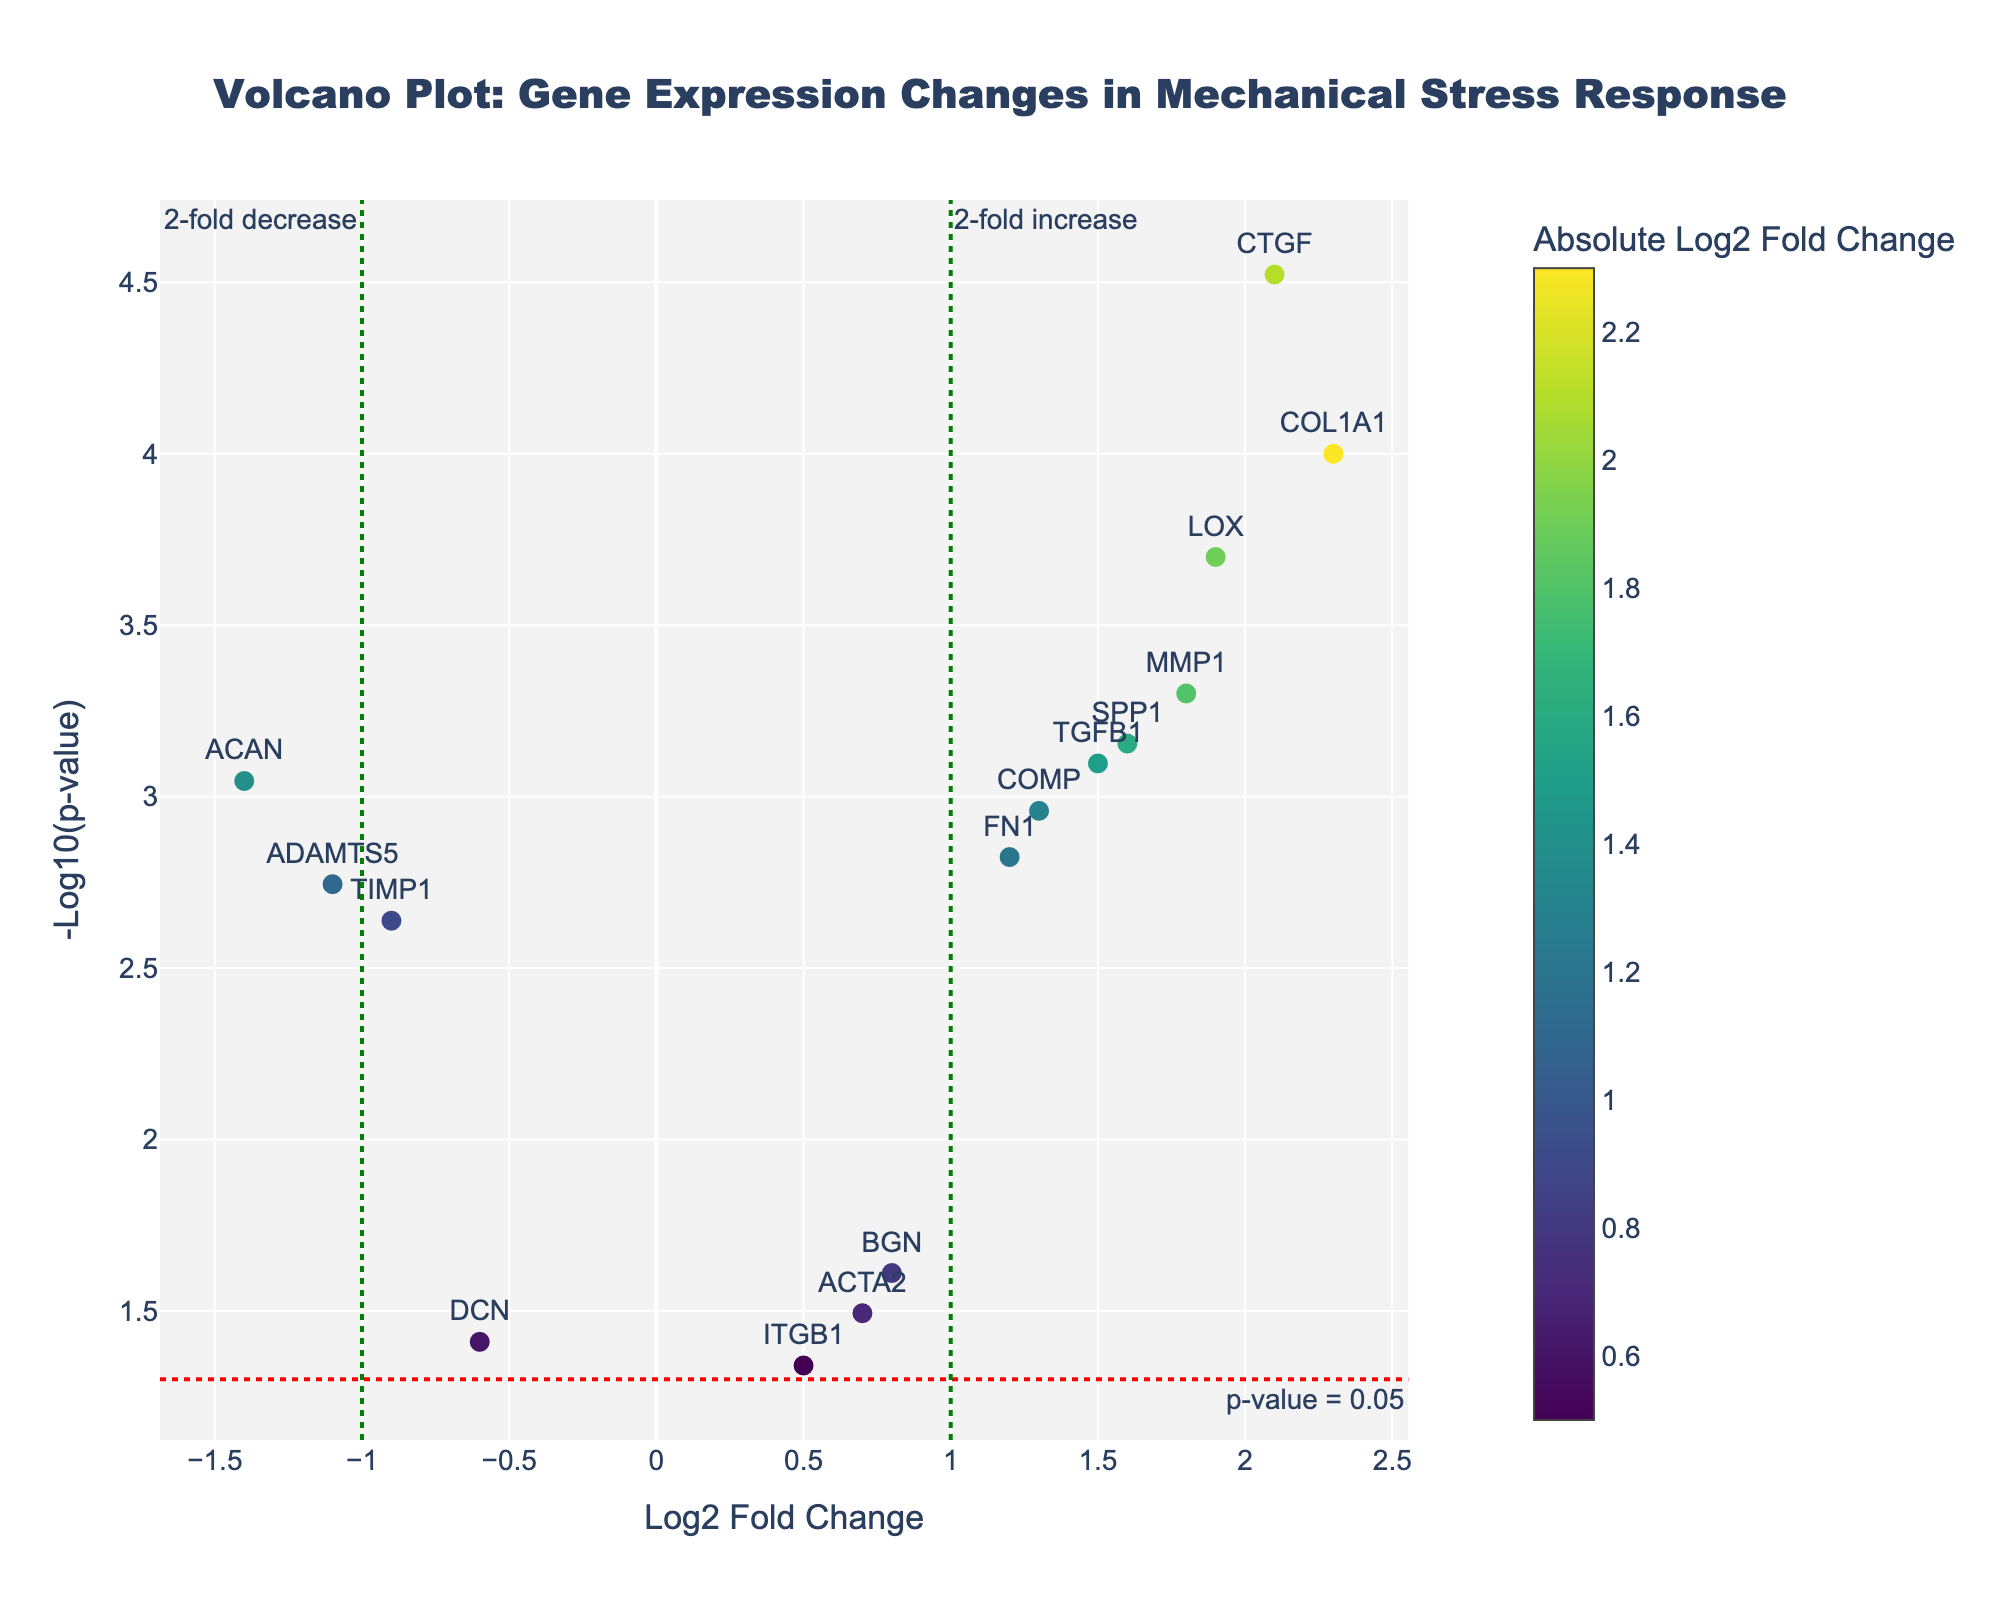What is the gene with the highest -log10(p-value)? Look for the data point with the highest value on the y-axis, which represents -log10(p-value). The gene corresponding to this point is CTGF.
Answer: CTGF How many genes have a log2 fold change greater than 2? Count the number of data points to the right of the vertical line at x=2 on the x-axis. There are no genes with a log2 fold change greater than 2.
Answer: 0 Which gene has the smallest p-value? The smallest p-value corresponds to the largest -log10(p-value). Identify the gene associated with the highest value on the y-axis. The gene is CTGF.
Answer: CTGF For the gene ADAMTS5, what is the log2 fold change and p-value? Locate the data point labeled ADAMTS5 and check its position in terms of x and y coordinates. The log2 fold change is -1.1, and the p-value (converted from -log10(p-value)) is approximately 0.0018.
Answer: -1.1 and 0.0018 Are there more genes upregulated (log2 fold change > 0) or downregulated (log2 fold change < 0)? Count the number of data points to the right of the log2 fold change x=0 line (upregulated) and compare it to the number on the left (downregulated). There are 11 upregulated and 4 downregulated.
Answer: Upregulated What do the colors of the data points represent? The color of each point indicates the absolute value of the log2 fold change, with a color scale provided as a guide.
Answer: Absolute Log2 Fold Change Which gene is the least statistically significant with a p-value still below 0.05? Look for the data point closest to the horizontal p-value threshold line at y=-log10(0.05) that is still above it. The gene is ITGB1.
Answer: ITGB1 How many genes have both a log2 fold change greater than 1 and a p-value smaller than 0.001? Locate the data points right of the vertical line at log2 fold change x=1 and above the horizontal line at -log10(p-value)=3. There are 4 genes: COL1A1, MMP1, CTGF, and LOX.
Answer: 4 Which upregulated gene has the highest p-value? Among the data points with log2 fold change > 0, find the one closest to the horizontal line at y=-log10(0.05) but still above it. The gene is ITGB1.
Answer: ITGB1 